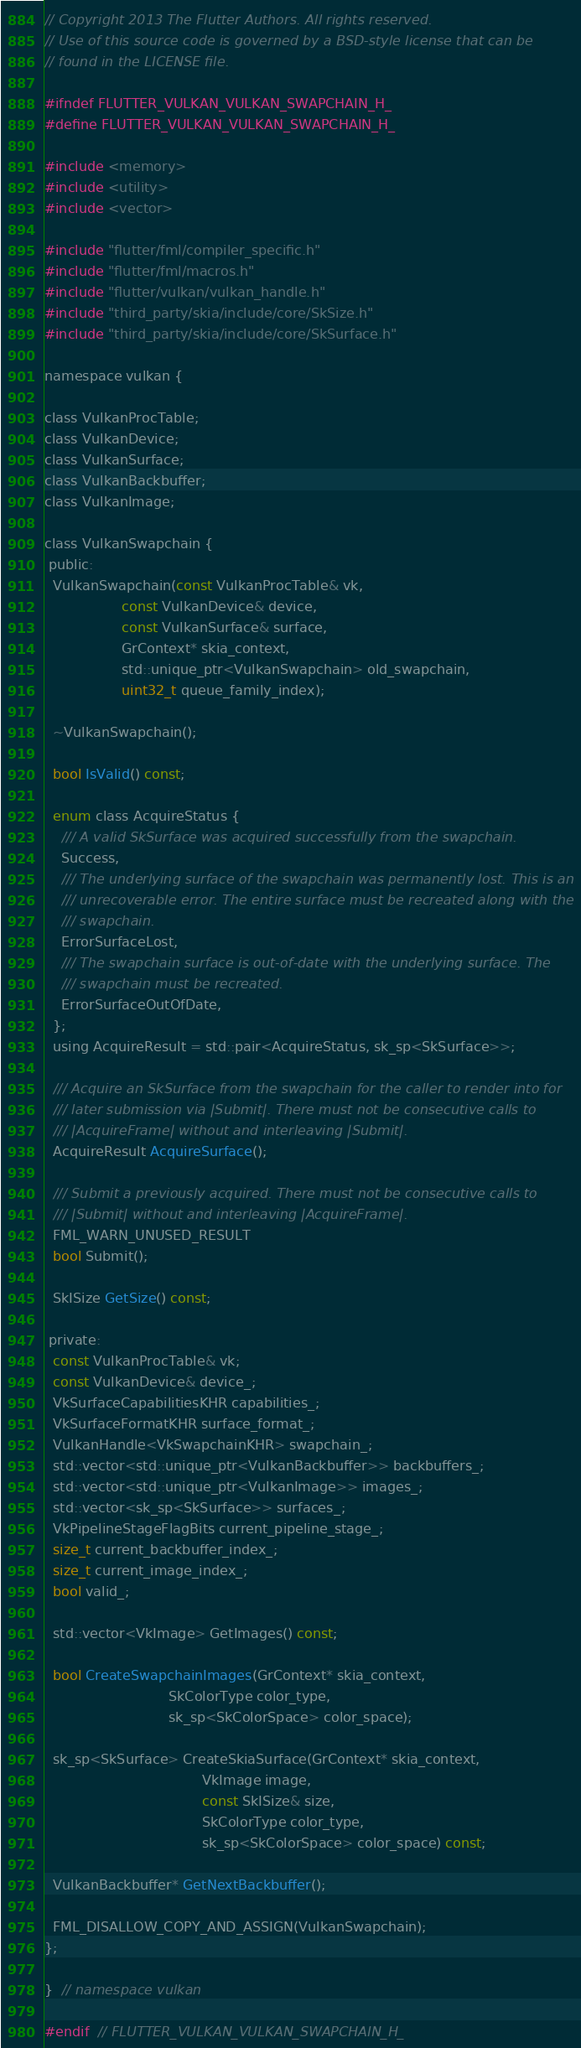Convert code to text. <code><loc_0><loc_0><loc_500><loc_500><_C_>// Copyright 2013 The Flutter Authors. All rights reserved.
// Use of this source code is governed by a BSD-style license that can be
// found in the LICENSE file.

#ifndef FLUTTER_VULKAN_VULKAN_SWAPCHAIN_H_
#define FLUTTER_VULKAN_VULKAN_SWAPCHAIN_H_

#include <memory>
#include <utility>
#include <vector>

#include "flutter/fml/compiler_specific.h"
#include "flutter/fml/macros.h"
#include "flutter/vulkan/vulkan_handle.h"
#include "third_party/skia/include/core/SkSize.h"
#include "third_party/skia/include/core/SkSurface.h"

namespace vulkan {

class VulkanProcTable;
class VulkanDevice;
class VulkanSurface;
class VulkanBackbuffer;
class VulkanImage;

class VulkanSwapchain {
 public:
  VulkanSwapchain(const VulkanProcTable& vk,
                  const VulkanDevice& device,
                  const VulkanSurface& surface,
                  GrContext* skia_context,
                  std::unique_ptr<VulkanSwapchain> old_swapchain,
                  uint32_t queue_family_index);

  ~VulkanSwapchain();

  bool IsValid() const;

  enum class AcquireStatus {
    /// A valid SkSurface was acquired successfully from the swapchain.
    Success,
    /// The underlying surface of the swapchain was permanently lost. This is an
    /// unrecoverable error. The entire surface must be recreated along with the
    /// swapchain.
    ErrorSurfaceLost,
    /// The swapchain surface is out-of-date with the underlying surface. The
    /// swapchain must be recreated.
    ErrorSurfaceOutOfDate,
  };
  using AcquireResult = std::pair<AcquireStatus, sk_sp<SkSurface>>;

  /// Acquire an SkSurface from the swapchain for the caller to render into for
  /// later submission via |Submit|. There must not be consecutive calls to
  /// |AcquireFrame| without and interleaving |Submit|.
  AcquireResult AcquireSurface();

  /// Submit a previously acquired. There must not be consecutive calls to
  /// |Submit| without and interleaving |AcquireFrame|.
  FML_WARN_UNUSED_RESULT
  bool Submit();

  SkISize GetSize() const;

 private:
  const VulkanProcTable& vk;
  const VulkanDevice& device_;
  VkSurfaceCapabilitiesKHR capabilities_;
  VkSurfaceFormatKHR surface_format_;
  VulkanHandle<VkSwapchainKHR> swapchain_;
  std::vector<std::unique_ptr<VulkanBackbuffer>> backbuffers_;
  std::vector<std::unique_ptr<VulkanImage>> images_;
  std::vector<sk_sp<SkSurface>> surfaces_;
  VkPipelineStageFlagBits current_pipeline_stage_;
  size_t current_backbuffer_index_;
  size_t current_image_index_;
  bool valid_;

  std::vector<VkImage> GetImages() const;

  bool CreateSwapchainImages(GrContext* skia_context,
                             SkColorType color_type,
                             sk_sp<SkColorSpace> color_space);

  sk_sp<SkSurface> CreateSkiaSurface(GrContext* skia_context,
                                     VkImage image,
                                     const SkISize& size,
                                     SkColorType color_type,
                                     sk_sp<SkColorSpace> color_space) const;

  VulkanBackbuffer* GetNextBackbuffer();

  FML_DISALLOW_COPY_AND_ASSIGN(VulkanSwapchain);
};

}  // namespace vulkan

#endif  // FLUTTER_VULKAN_VULKAN_SWAPCHAIN_H_
</code> 